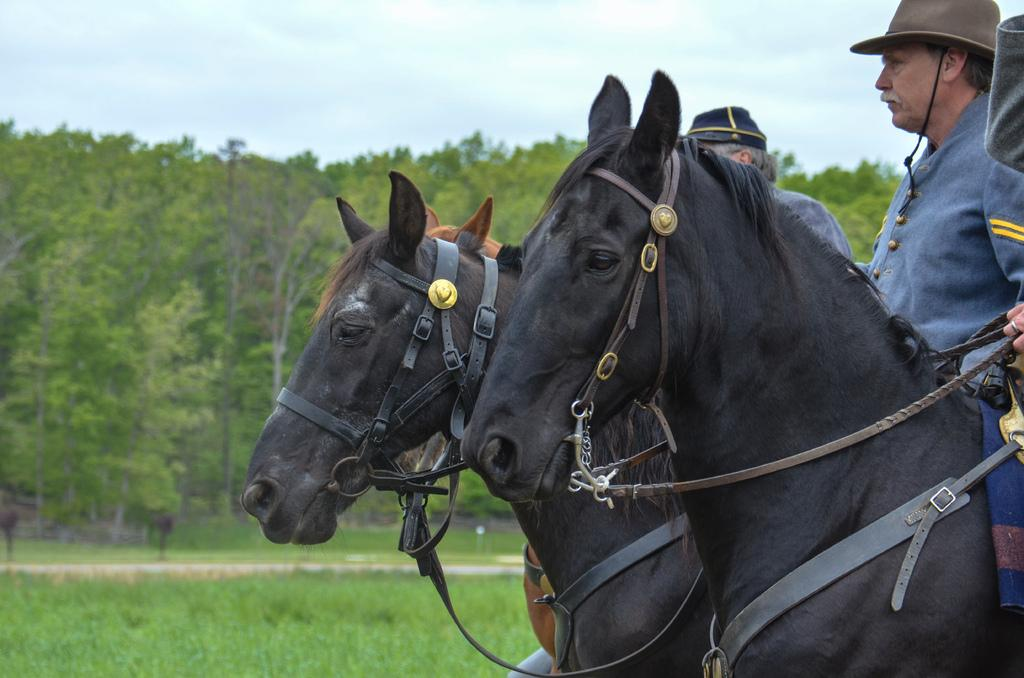What are the people in the image doing? The people in the image are sitting on horses. What colors can be seen on the horses? The horses are black and brown in color. What type of natural environment is visible in the image? There are trees visible in the image. What is visible above the people and horses in the image? The sky is visible in the image. What type of song is being sung by the trees in the image? There are no trees singing in the image; they are simply part of the natural environment. How does the hate in the image manifest itself? There is no hate present in the image; it is a peaceful scene of people riding horses. 